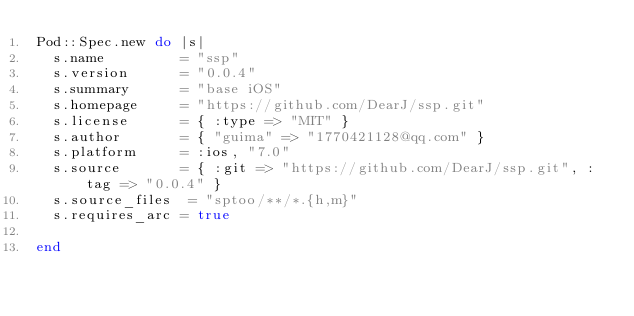<code> <loc_0><loc_0><loc_500><loc_500><_Ruby_>Pod::Spec.new do |s|
  s.name         = "ssp"
  s.version      = "0.0.4"
  s.summary      = "base iOS"
  s.homepage     = "https://github.com/DearJ/ssp.git"
  s.license      = { :type => "MIT" }
  s.author       = { "guima" => "1770421128@qq.com" }
  s.platform     = :ios, "7.0"
  s.source       = { :git => "https://github.com/DearJ/ssp.git", :tag => "0.0.4" }
  s.source_files  = "sptoo/**/*.{h,m}"
  s.requires_arc = true

end
</code> 